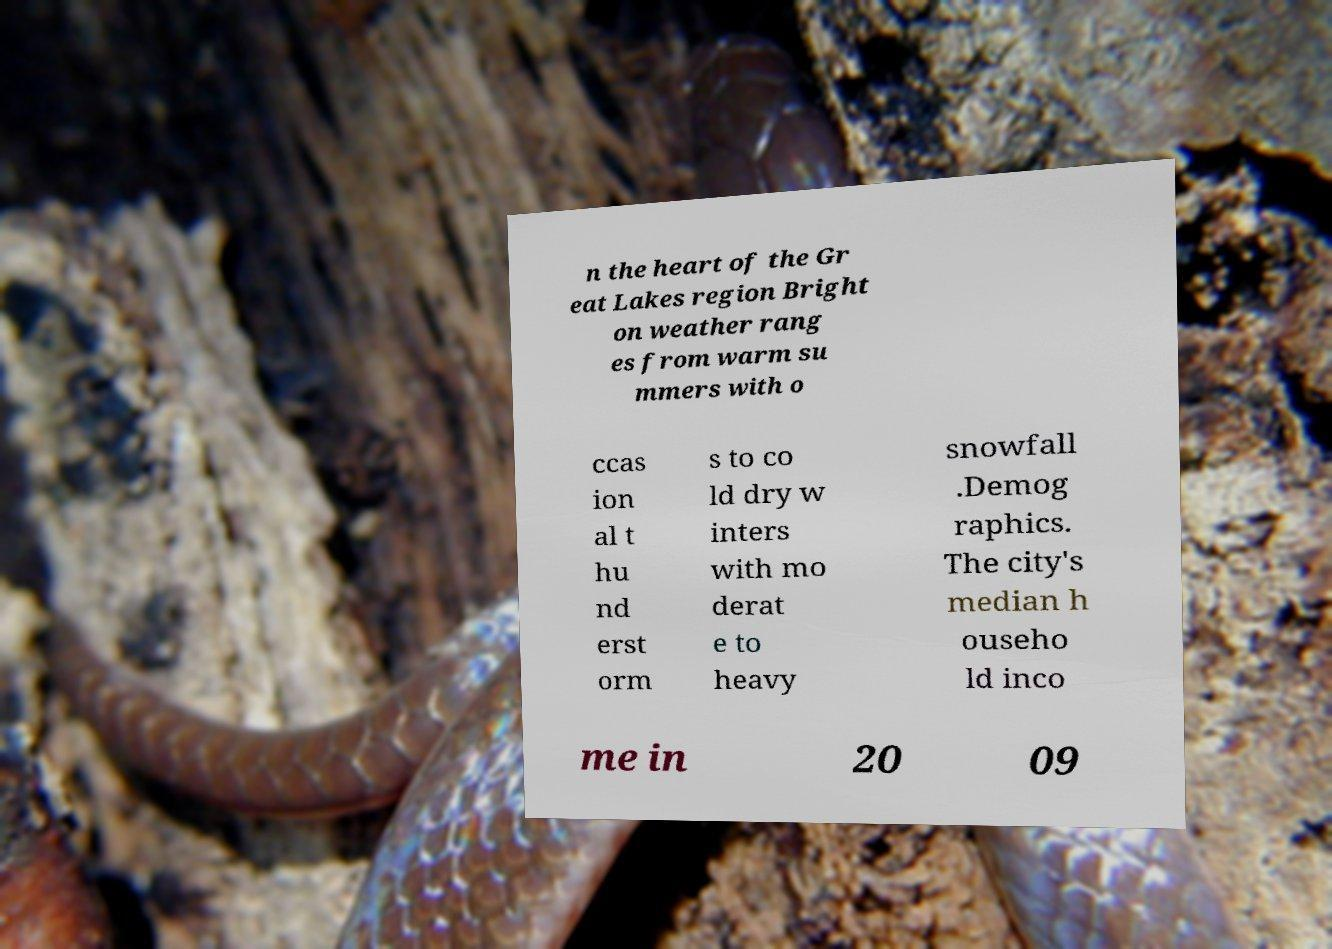Could you extract and type out the text from this image? n the heart of the Gr eat Lakes region Bright on weather rang es from warm su mmers with o ccas ion al t hu nd erst orm s to co ld dry w inters with mo derat e to heavy snowfall .Demog raphics. The city's median h ouseho ld inco me in 20 09 